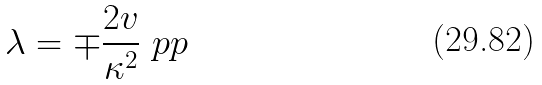Convert formula to latex. <formula><loc_0><loc_0><loc_500><loc_500>\lambda = \mp \frac { 2 v } { \kappa ^ { 2 } } \ p p</formula> 